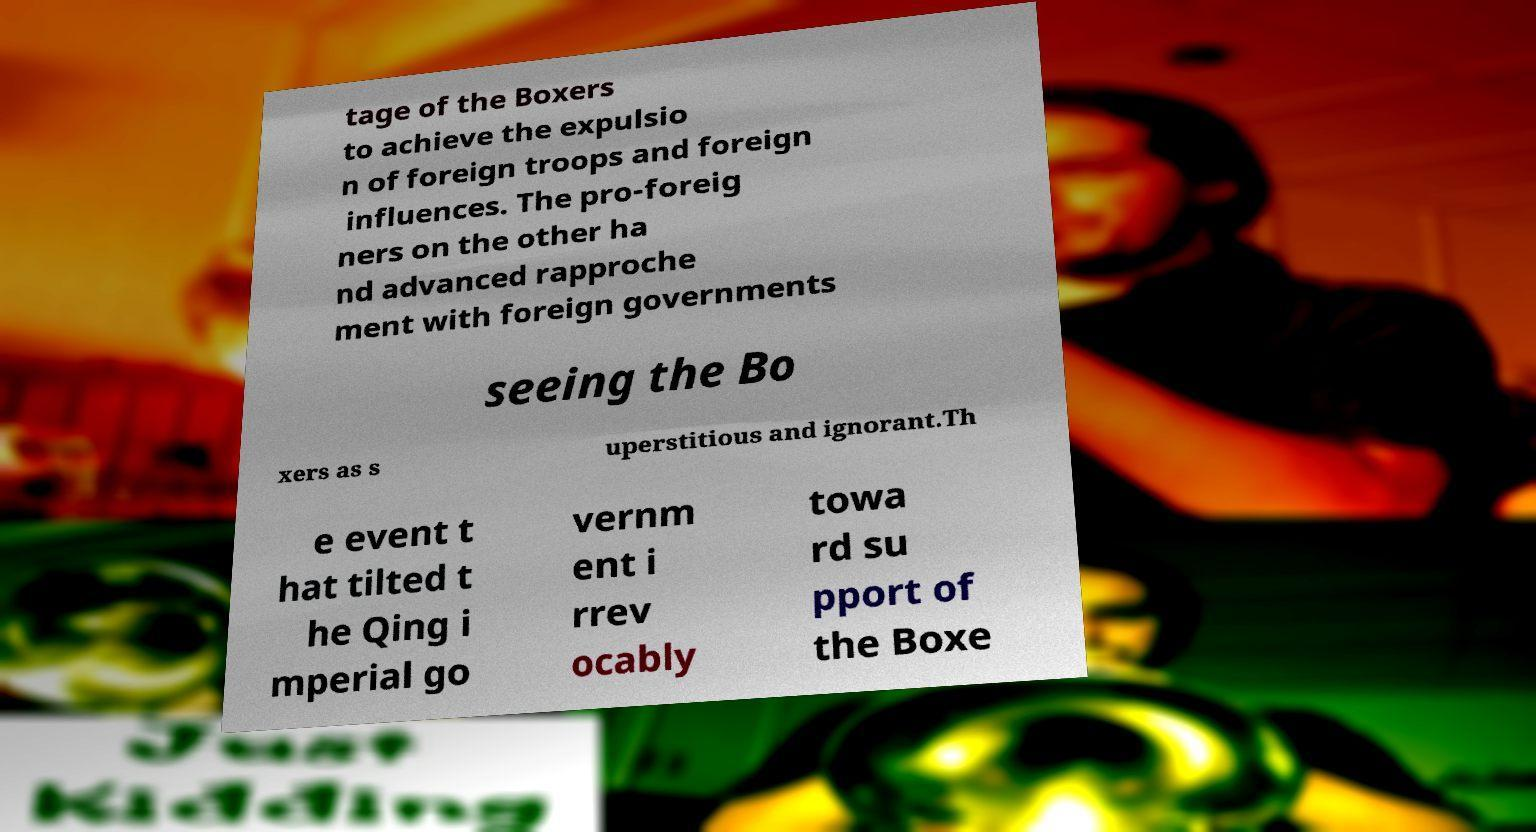Could you extract and type out the text from this image? tage of the Boxers to achieve the expulsio n of foreign troops and foreign influences. The pro-foreig ners on the other ha nd advanced rapproche ment with foreign governments seeing the Bo xers as s uperstitious and ignorant.Th e event t hat tilted t he Qing i mperial go vernm ent i rrev ocably towa rd su pport of the Boxe 